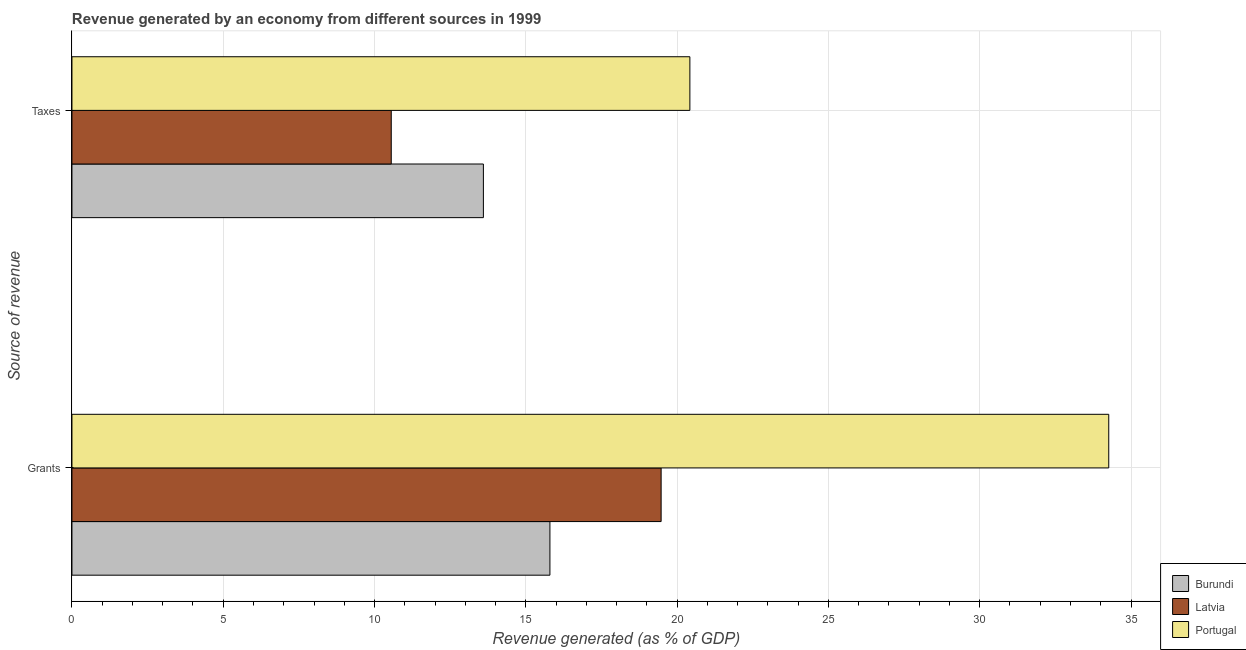How many different coloured bars are there?
Offer a very short reply. 3. How many groups of bars are there?
Offer a very short reply. 2. Are the number of bars on each tick of the Y-axis equal?
Give a very brief answer. Yes. What is the label of the 1st group of bars from the top?
Provide a short and direct response. Taxes. What is the revenue generated by taxes in Burundi?
Offer a very short reply. 13.6. Across all countries, what is the maximum revenue generated by taxes?
Keep it short and to the point. 20.42. Across all countries, what is the minimum revenue generated by grants?
Make the answer very short. 15.8. In which country was the revenue generated by taxes minimum?
Make the answer very short. Latvia. What is the total revenue generated by taxes in the graph?
Your answer should be very brief. 44.57. What is the difference between the revenue generated by grants in Latvia and that in Portugal?
Offer a terse response. -14.79. What is the difference between the revenue generated by taxes in Burundi and the revenue generated by grants in Latvia?
Provide a short and direct response. -5.87. What is the average revenue generated by taxes per country?
Provide a short and direct response. 14.86. What is the difference between the revenue generated by grants and revenue generated by taxes in Burundi?
Keep it short and to the point. 2.2. In how many countries, is the revenue generated by taxes greater than 4 %?
Offer a very short reply. 3. What is the ratio of the revenue generated by grants in Latvia to that in Burundi?
Offer a very short reply. 1.23. Is the revenue generated by grants in Burundi less than that in Portugal?
Provide a short and direct response. Yes. What does the 2nd bar from the top in Grants represents?
Keep it short and to the point. Latvia. What does the 1st bar from the bottom in Taxes represents?
Offer a terse response. Burundi. Are the values on the major ticks of X-axis written in scientific E-notation?
Provide a succinct answer. No. Does the graph contain any zero values?
Your answer should be very brief. No. Where does the legend appear in the graph?
Make the answer very short. Bottom right. How many legend labels are there?
Offer a very short reply. 3. What is the title of the graph?
Give a very brief answer. Revenue generated by an economy from different sources in 1999. What is the label or title of the X-axis?
Your answer should be compact. Revenue generated (as % of GDP). What is the label or title of the Y-axis?
Give a very brief answer. Source of revenue. What is the Revenue generated (as % of GDP) of Burundi in Grants?
Provide a short and direct response. 15.8. What is the Revenue generated (as % of GDP) of Latvia in Grants?
Your response must be concise. 19.47. What is the Revenue generated (as % of GDP) in Portugal in Grants?
Keep it short and to the point. 34.26. What is the Revenue generated (as % of GDP) of Burundi in Taxes?
Your response must be concise. 13.6. What is the Revenue generated (as % of GDP) in Latvia in Taxes?
Offer a very short reply. 10.55. What is the Revenue generated (as % of GDP) of Portugal in Taxes?
Your answer should be very brief. 20.42. Across all Source of revenue, what is the maximum Revenue generated (as % of GDP) of Burundi?
Offer a very short reply. 15.8. Across all Source of revenue, what is the maximum Revenue generated (as % of GDP) of Latvia?
Your answer should be very brief. 19.47. Across all Source of revenue, what is the maximum Revenue generated (as % of GDP) in Portugal?
Make the answer very short. 34.26. Across all Source of revenue, what is the minimum Revenue generated (as % of GDP) of Burundi?
Your answer should be very brief. 13.6. Across all Source of revenue, what is the minimum Revenue generated (as % of GDP) of Latvia?
Ensure brevity in your answer.  10.55. Across all Source of revenue, what is the minimum Revenue generated (as % of GDP) of Portugal?
Give a very brief answer. 20.42. What is the total Revenue generated (as % of GDP) of Burundi in the graph?
Provide a short and direct response. 29.39. What is the total Revenue generated (as % of GDP) in Latvia in the graph?
Keep it short and to the point. 30.02. What is the total Revenue generated (as % of GDP) of Portugal in the graph?
Your answer should be compact. 54.69. What is the difference between the Revenue generated (as % of GDP) of Burundi in Grants and that in Taxes?
Keep it short and to the point. 2.2. What is the difference between the Revenue generated (as % of GDP) of Latvia in Grants and that in Taxes?
Your answer should be very brief. 8.92. What is the difference between the Revenue generated (as % of GDP) in Portugal in Grants and that in Taxes?
Offer a very short reply. 13.84. What is the difference between the Revenue generated (as % of GDP) in Burundi in Grants and the Revenue generated (as % of GDP) in Latvia in Taxes?
Provide a succinct answer. 5.24. What is the difference between the Revenue generated (as % of GDP) of Burundi in Grants and the Revenue generated (as % of GDP) of Portugal in Taxes?
Provide a succinct answer. -4.63. What is the difference between the Revenue generated (as % of GDP) in Latvia in Grants and the Revenue generated (as % of GDP) in Portugal in Taxes?
Ensure brevity in your answer.  -0.95. What is the average Revenue generated (as % of GDP) in Burundi per Source of revenue?
Provide a succinct answer. 14.7. What is the average Revenue generated (as % of GDP) of Latvia per Source of revenue?
Make the answer very short. 15.01. What is the average Revenue generated (as % of GDP) of Portugal per Source of revenue?
Offer a very short reply. 27.34. What is the difference between the Revenue generated (as % of GDP) in Burundi and Revenue generated (as % of GDP) in Latvia in Grants?
Offer a terse response. -3.68. What is the difference between the Revenue generated (as % of GDP) of Burundi and Revenue generated (as % of GDP) of Portugal in Grants?
Your response must be concise. -18.47. What is the difference between the Revenue generated (as % of GDP) in Latvia and Revenue generated (as % of GDP) in Portugal in Grants?
Provide a succinct answer. -14.79. What is the difference between the Revenue generated (as % of GDP) of Burundi and Revenue generated (as % of GDP) of Latvia in Taxes?
Provide a short and direct response. 3.05. What is the difference between the Revenue generated (as % of GDP) in Burundi and Revenue generated (as % of GDP) in Portugal in Taxes?
Offer a terse response. -6.82. What is the difference between the Revenue generated (as % of GDP) in Latvia and Revenue generated (as % of GDP) in Portugal in Taxes?
Ensure brevity in your answer.  -9.87. What is the ratio of the Revenue generated (as % of GDP) in Burundi in Grants to that in Taxes?
Your response must be concise. 1.16. What is the ratio of the Revenue generated (as % of GDP) of Latvia in Grants to that in Taxes?
Keep it short and to the point. 1.85. What is the ratio of the Revenue generated (as % of GDP) in Portugal in Grants to that in Taxes?
Ensure brevity in your answer.  1.68. What is the difference between the highest and the second highest Revenue generated (as % of GDP) of Burundi?
Provide a short and direct response. 2.2. What is the difference between the highest and the second highest Revenue generated (as % of GDP) in Latvia?
Give a very brief answer. 8.92. What is the difference between the highest and the second highest Revenue generated (as % of GDP) of Portugal?
Your answer should be very brief. 13.84. What is the difference between the highest and the lowest Revenue generated (as % of GDP) in Burundi?
Offer a terse response. 2.2. What is the difference between the highest and the lowest Revenue generated (as % of GDP) in Latvia?
Give a very brief answer. 8.92. What is the difference between the highest and the lowest Revenue generated (as % of GDP) of Portugal?
Provide a short and direct response. 13.84. 